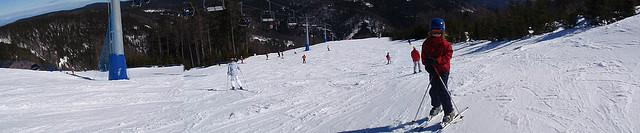What is a term used for this place? snowboarding resort 